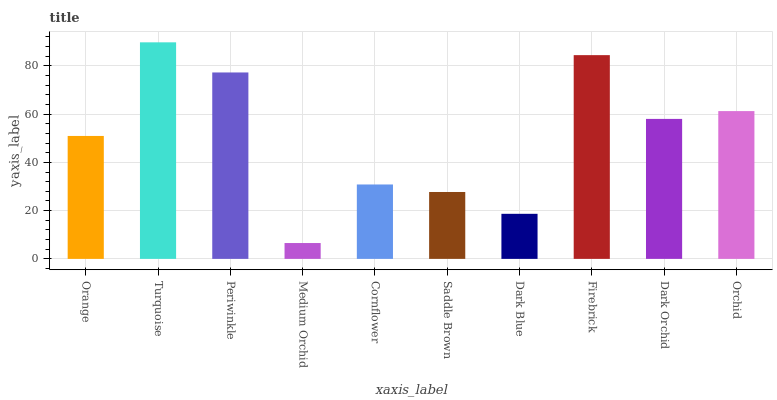Is Medium Orchid the minimum?
Answer yes or no. Yes. Is Turquoise the maximum?
Answer yes or no. Yes. Is Periwinkle the minimum?
Answer yes or no. No. Is Periwinkle the maximum?
Answer yes or no. No. Is Turquoise greater than Periwinkle?
Answer yes or no. Yes. Is Periwinkle less than Turquoise?
Answer yes or no. Yes. Is Periwinkle greater than Turquoise?
Answer yes or no. No. Is Turquoise less than Periwinkle?
Answer yes or no. No. Is Dark Orchid the high median?
Answer yes or no. Yes. Is Orange the low median?
Answer yes or no. Yes. Is Medium Orchid the high median?
Answer yes or no. No. Is Firebrick the low median?
Answer yes or no. No. 